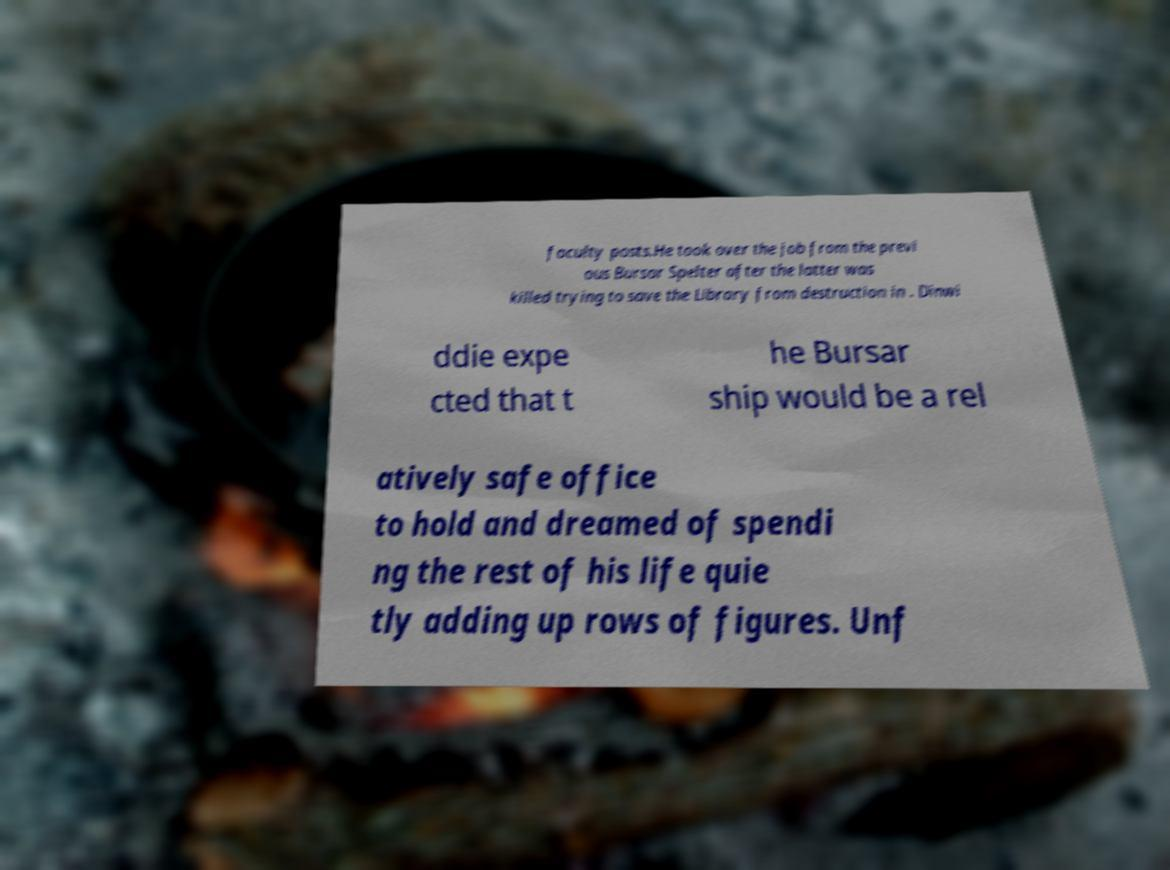Can you read and provide the text displayed in the image?This photo seems to have some interesting text. Can you extract and type it out for me? faculty posts.He took over the job from the previ ous Bursar Spelter after the latter was killed trying to save the Library from destruction in . Dinwi ddie expe cted that t he Bursar ship would be a rel atively safe office to hold and dreamed of spendi ng the rest of his life quie tly adding up rows of figures. Unf 